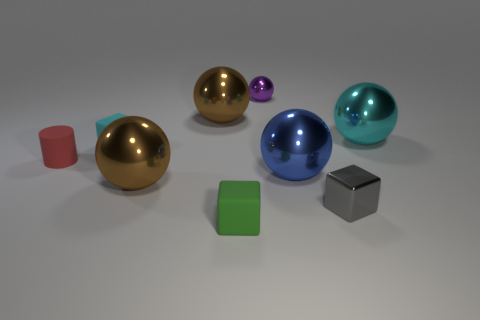There is a big blue thing that is to the left of the gray thing left of the cyan metallic object; is there a tiny green rubber thing behind it?
Offer a very short reply. No. There is a small thing that is in front of the small shiny block; does it have the same shape as the cyan object that is to the left of the big cyan metallic ball?
Provide a succinct answer. Yes. What is the color of the block that is made of the same material as the large cyan sphere?
Your answer should be compact. Gray. Are there fewer small red rubber things behind the tiny matte cylinder than tiny cyan objects?
Offer a terse response. Yes. There is a brown metallic ball that is in front of the brown metal thing on the right side of the large brown ball that is in front of the small cyan matte object; what size is it?
Offer a terse response. Large. Does the block that is on the right side of the tiny green matte thing have the same material as the tiny green thing?
Provide a short and direct response. No. Is there anything else that is the same shape as the small red matte object?
Keep it short and to the point. No. How many objects are either big brown things or small red things?
Your answer should be compact. 3. There is a purple metal thing that is the same shape as the blue metallic object; what size is it?
Give a very brief answer. Small. How many other objects are the same color as the tiny rubber cylinder?
Offer a very short reply. 0. 